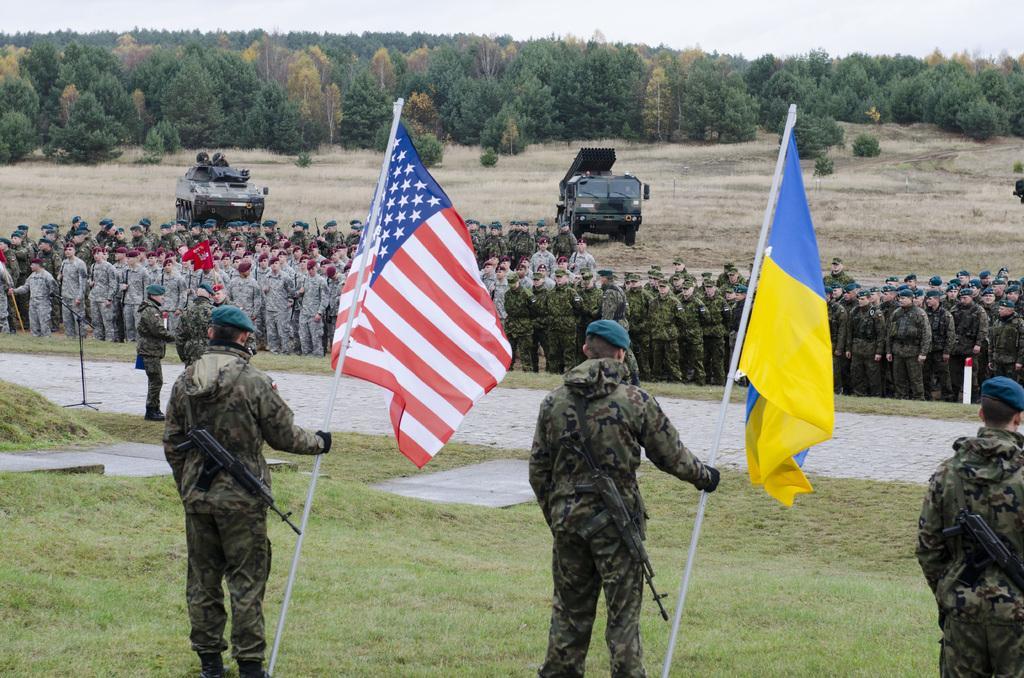Can you describe this image briefly? In this picture there are two persons standing and holding the flags and there is a person standing. At the back there are group of people standing and there are vehicles and trees. On the left side of the image there is a microphone. At the top there is sky. At the bottom there is grass and there is a road. 